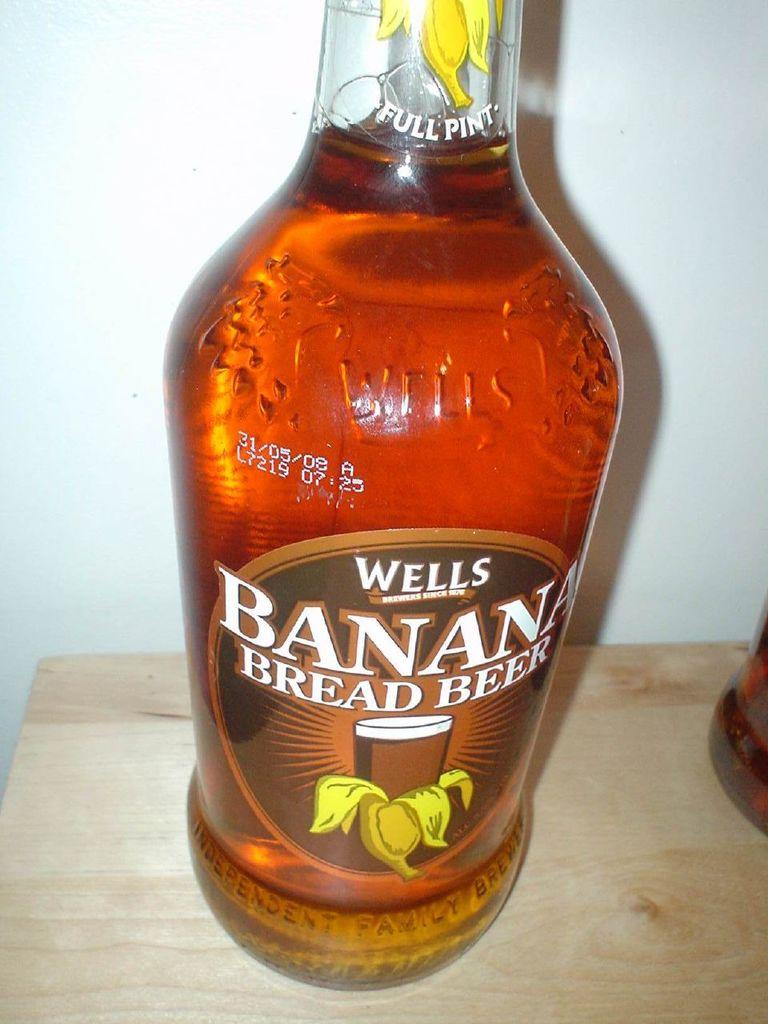What is placed on the table in the image? There is a wine bottle placed on a table. Can you describe the other wine bottle in the image? There is another wine bottle in the right corner of the image. What type of wire can be seen connecting the two wine bottles in the image? There is no wire connecting the two wine bottles in the image. What mountain range is visible in the background of the image? There is no mountain range visible in the image; it only features two wine bottles. 